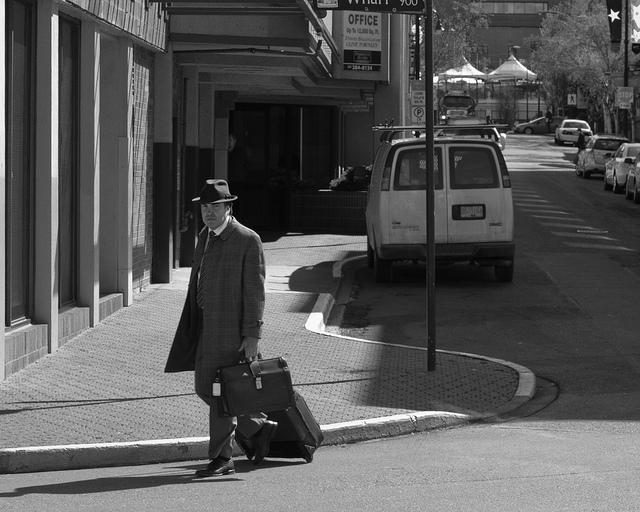What is the man carrying?
Quick response, please. Briefcase. Why does the sidewalk bulge out?
Short answer required. Crosswalk. What is he doing?
Concise answer only. Walking. What is the man carrying in the large case?
Be succinct. Clothes. What is inside the bag?
Write a very short answer. Clothes. How many people are standing on the side of the street?
Quick response, please. 1. What type of coat is the man wearing?
Answer briefly. Overcoat. How many bags are there?
Short answer required. 2. What instrument in with the luggage?
Answer briefly. Flute. 